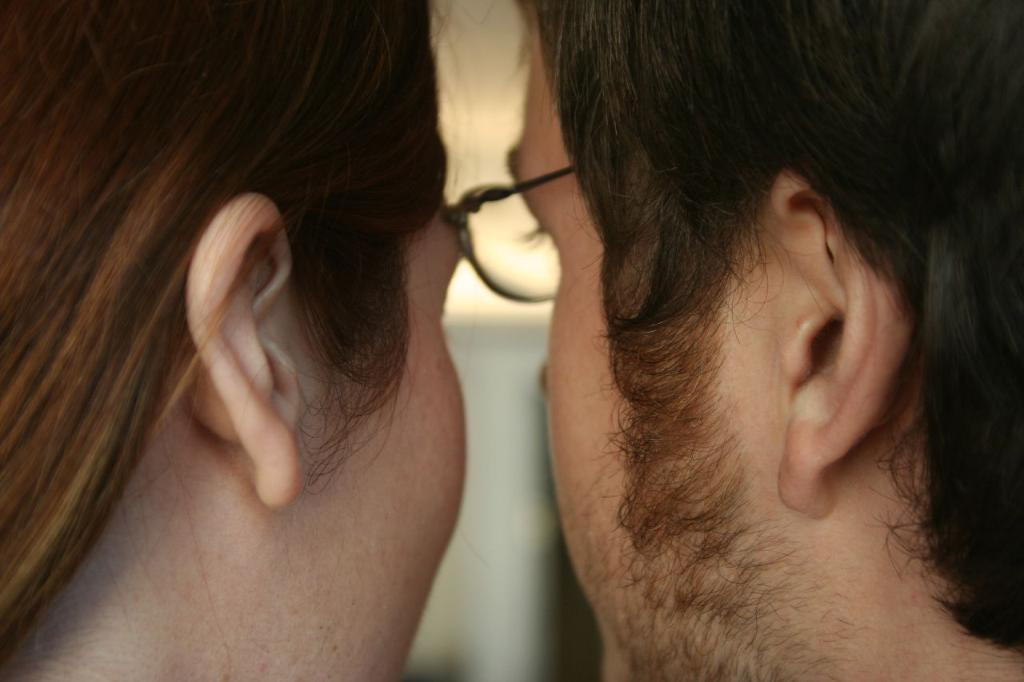How many people are present in the image? There are two people in the image. Can you describe any specific features of one of the people? One person is wearing glasses (specs). What can be observed about the background of the image? The background of the image is blurred. How many toes can be seen on the person wearing the glasses in the image? There is no information about the person's toes in the image, as the focus is on their glasses. 